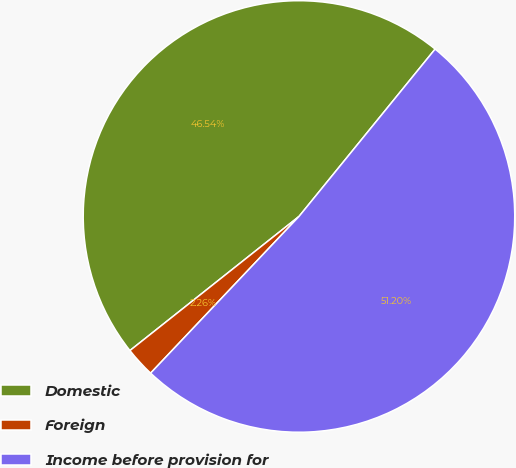Convert chart to OTSL. <chart><loc_0><loc_0><loc_500><loc_500><pie_chart><fcel>Domestic<fcel>Foreign<fcel>Income before provision for<nl><fcel>46.54%<fcel>2.26%<fcel>51.2%<nl></chart> 